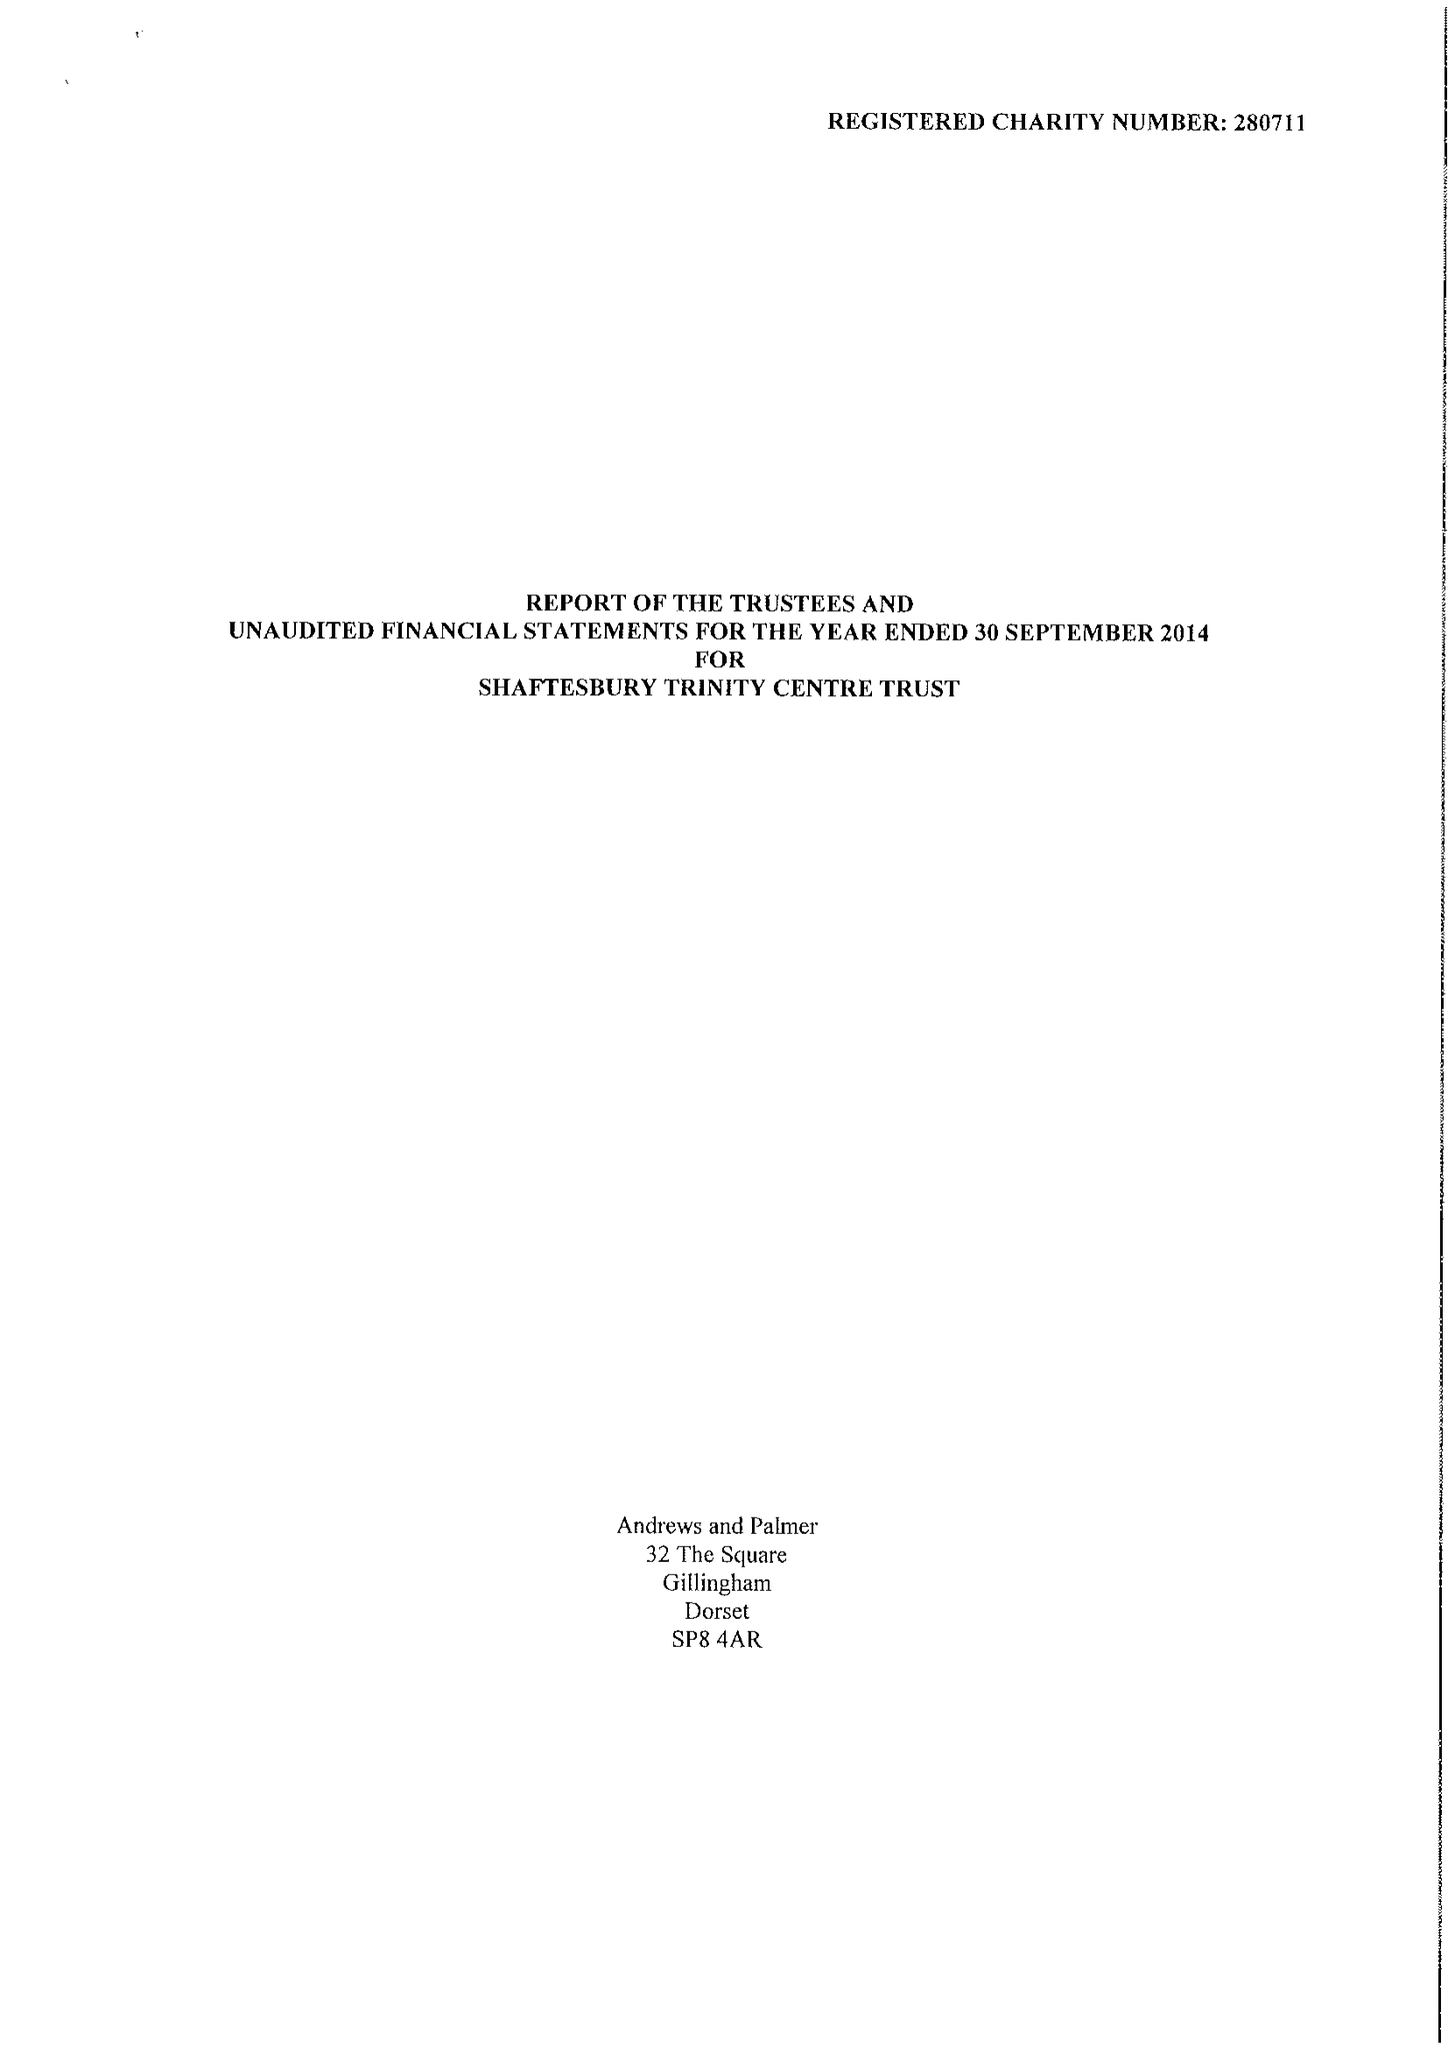What is the value for the charity_number?
Answer the question using a single word or phrase. 280711 